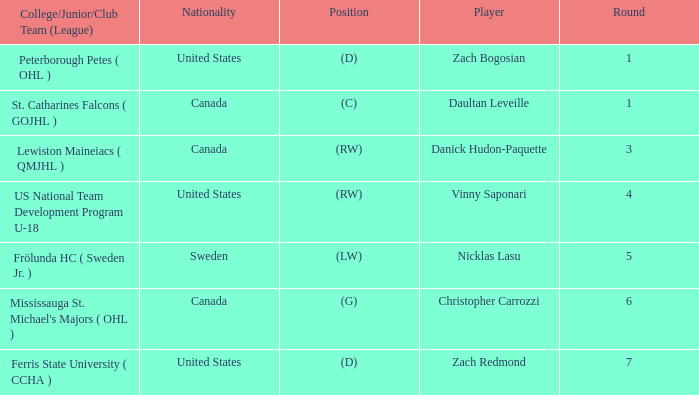What is Daultan Leveille's Position? (C). 